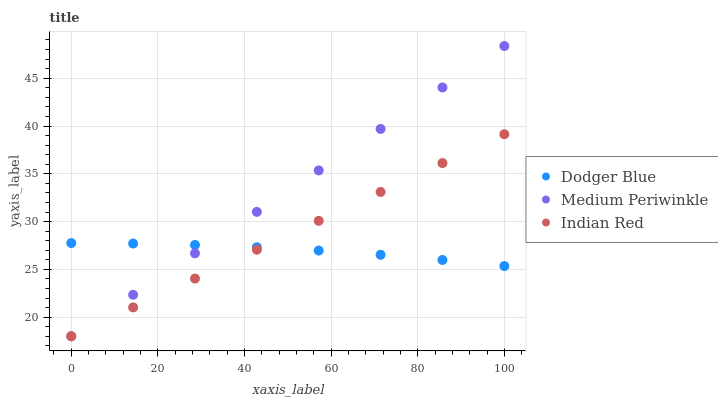Does Dodger Blue have the minimum area under the curve?
Answer yes or no. Yes. Does Medium Periwinkle have the maximum area under the curve?
Answer yes or no. Yes. Does Indian Red have the minimum area under the curve?
Answer yes or no. No. Does Indian Red have the maximum area under the curve?
Answer yes or no. No. Is Indian Red the smoothest?
Answer yes or no. Yes. Is Dodger Blue the roughest?
Answer yes or no. Yes. Is Dodger Blue the smoothest?
Answer yes or no. No. Is Indian Red the roughest?
Answer yes or no. No. Does Medium Periwinkle have the lowest value?
Answer yes or no. Yes. Does Dodger Blue have the lowest value?
Answer yes or no. No. Does Medium Periwinkle have the highest value?
Answer yes or no. Yes. Does Indian Red have the highest value?
Answer yes or no. No. Does Indian Red intersect Medium Periwinkle?
Answer yes or no. Yes. Is Indian Red less than Medium Periwinkle?
Answer yes or no. No. Is Indian Red greater than Medium Periwinkle?
Answer yes or no. No. 